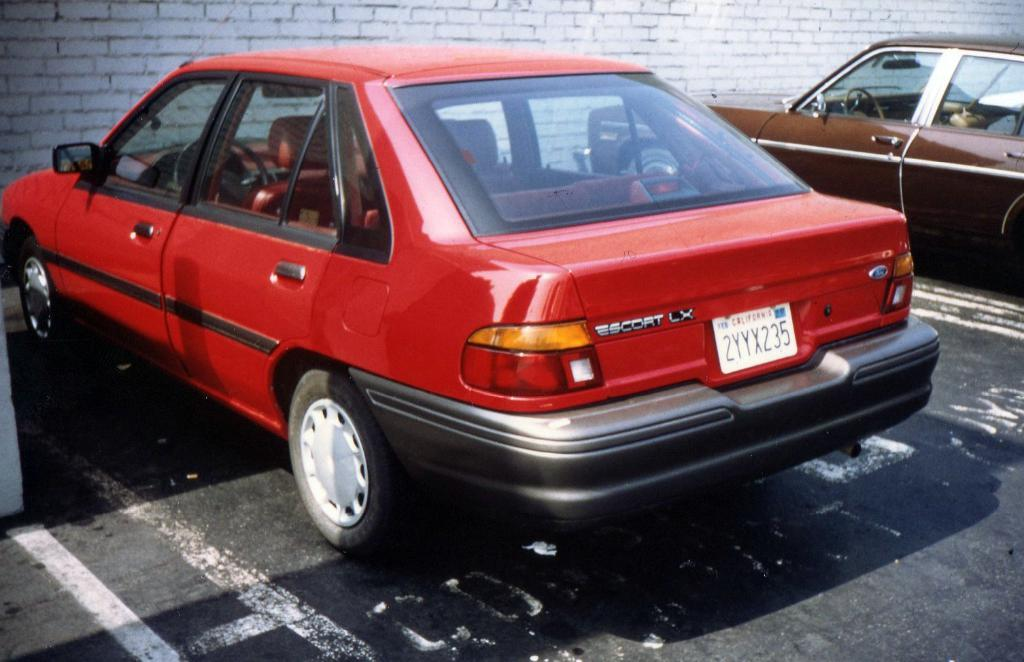What type of vehicles can be seen in the image? There are cars in the image. What is written on the board in the image? There are numbers written on a board in the image. What can be seen on the road in the image? White lines are visible on the road in the image. What color is the wall in the background of the image? There is a white-colored wall in the background of the image. How many nails are used to hold the scale in the image? There is no scale or nails present in the image. 